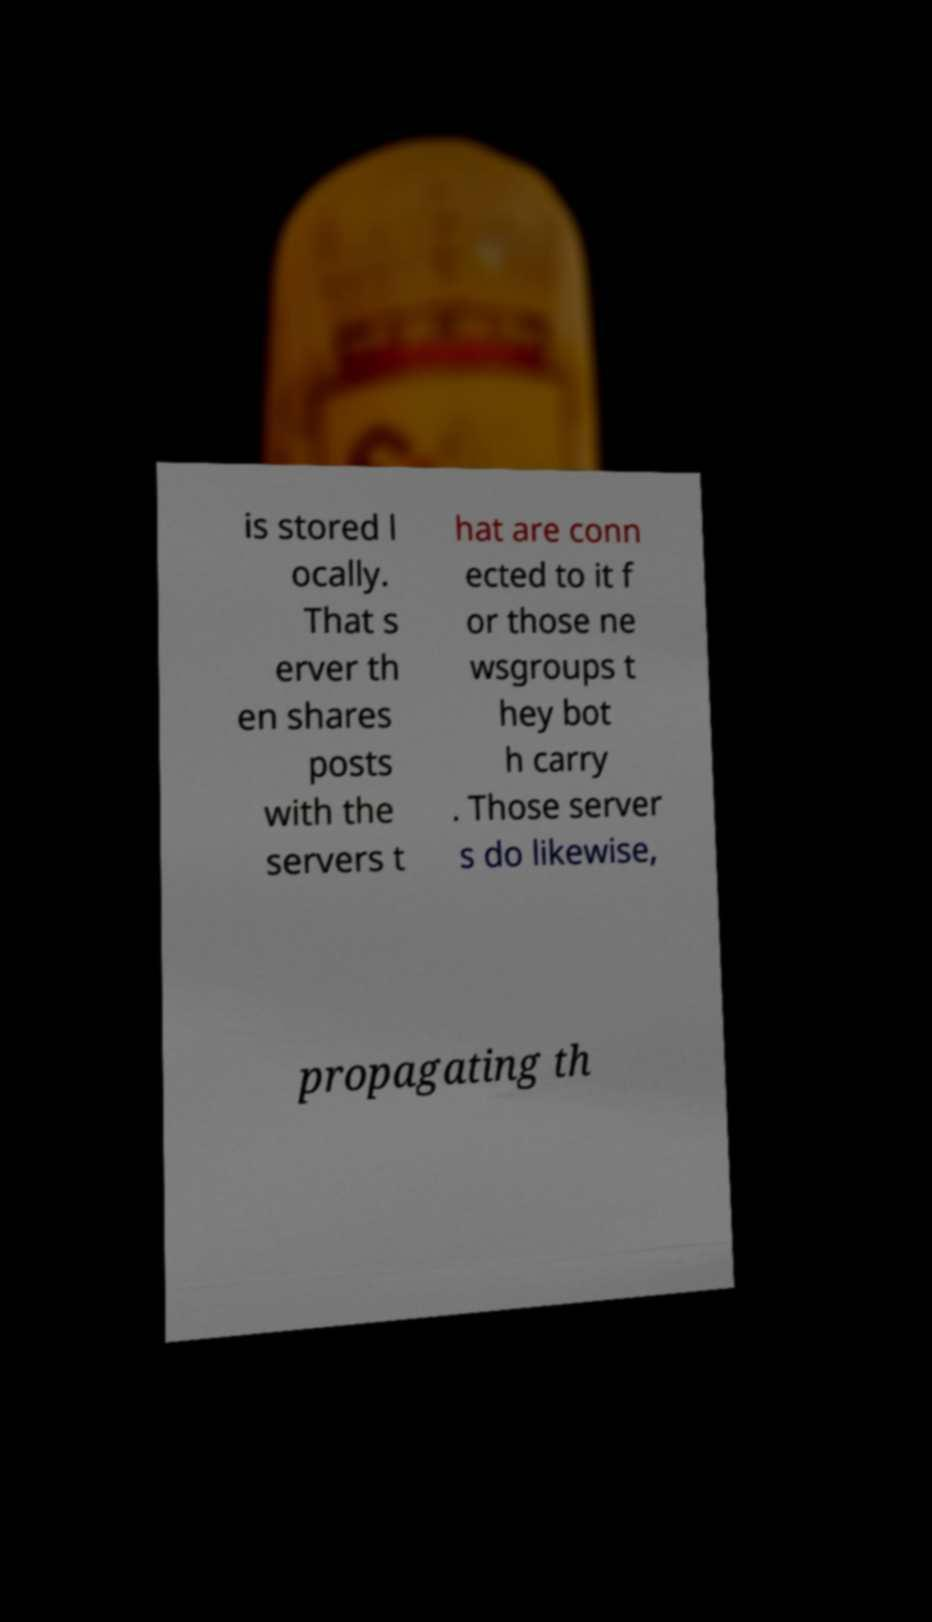Could you extract and type out the text from this image? is stored l ocally. That s erver th en shares posts with the servers t hat are conn ected to it f or those ne wsgroups t hey bot h carry . Those server s do likewise, propagating th 